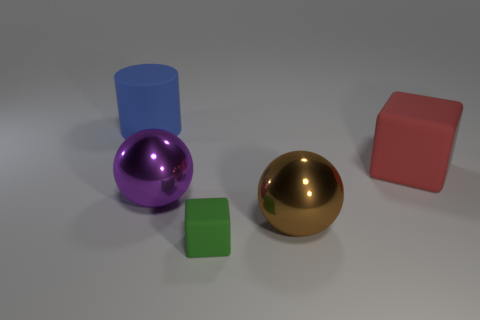Is there a ball of the same size as the green rubber cube?
Give a very brief answer. No. There is a large blue object; is it the same shape as the large matte object that is in front of the big blue matte object?
Offer a very short reply. No. There is a cube that is behind the large brown metallic sphere; does it have the same size as the cube in front of the purple ball?
Your response must be concise. No. What number of other things are the same shape as the red matte thing?
Your answer should be very brief. 1. There is a object that is to the right of the big metallic object that is to the right of the green block; what is it made of?
Offer a terse response. Rubber. How many shiny objects are either red cubes or small green cubes?
Make the answer very short. 0. Are there any other things that have the same material as the big blue cylinder?
Ensure brevity in your answer.  Yes. Is there a big blue thing that is right of the big metal sphere on the left side of the big brown object?
Provide a succinct answer. No. What number of things are large matte things on the right side of the purple shiny ball or blocks that are to the left of the large red block?
Offer a very short reply. 2. Are there any other things that have the same color as the large cylinder?
Provide a succinct answer. No. 